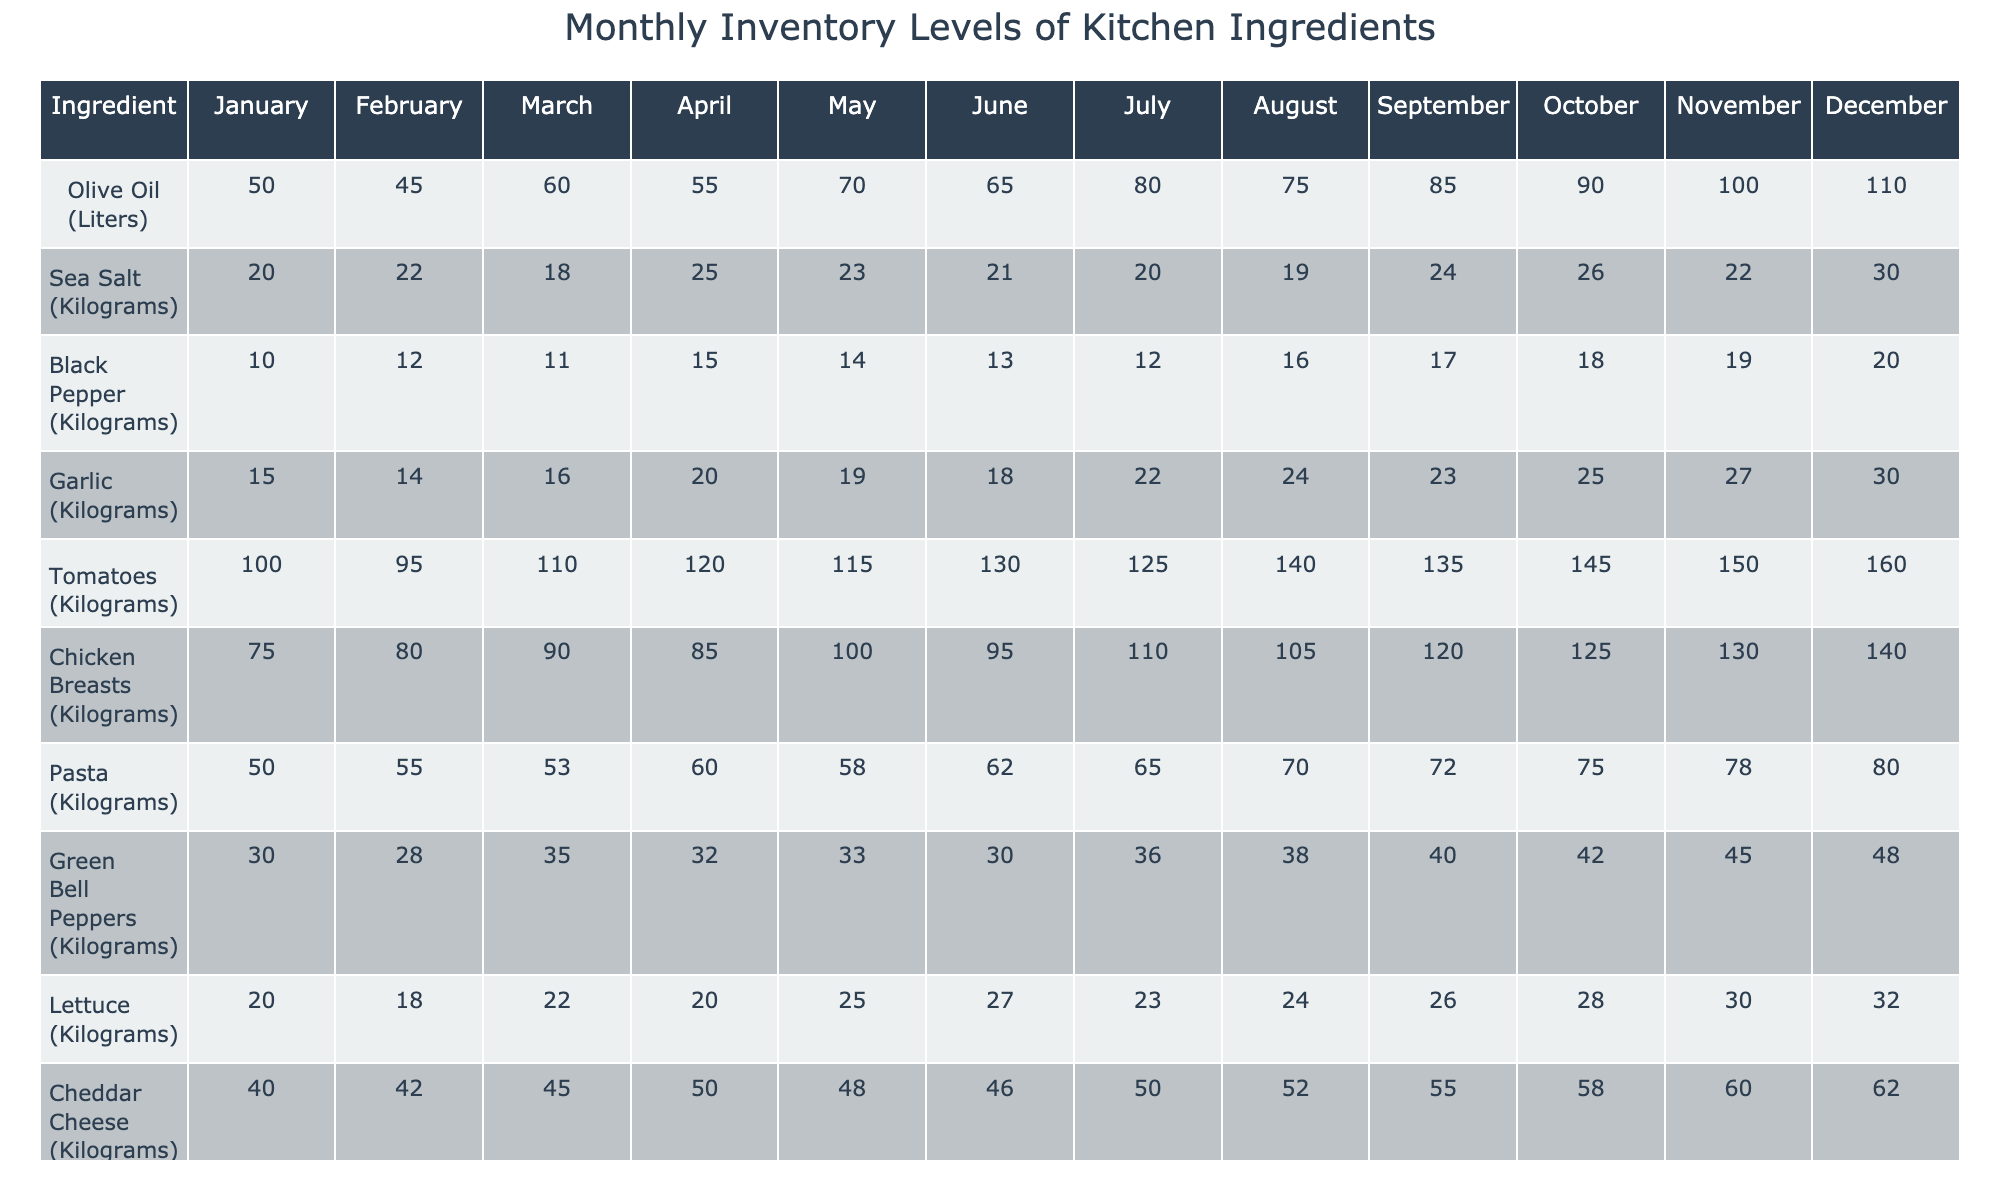What was the highest stock level of Olive Oil? The Olive Oil stock levels for the months are listed as follows: 50, 45, 60, 55, 70, 65, 80, 75, 85, 90, 100, and 110. The highest number is 110 in December.
Answer: 110 Which month had the lowest inventory of Sea Salt? The Sea Salt inventory monthly data is 20, 22, 18, 25, 23, 21, 20, 19, 24, 26, 22, and 30. The lowest inventory is 18, which occurred in March.
Answer: 18 What was the total amount of Garlic received from January to March? The Garlic inventory levels from January to March are 15, 14, and 16. To find the total: 15 + 14 + 16 = 45.
Answer: 45 Did the amount of Lettuce in April exceed the amount in March? The Lettuce amounts are 22 in March and 20 in April. Since 20 is less than 22, April did not exceed March.
Answer: No In which month did the inventory of Tomatoes increase the most compared to the previous one? The inventory values of Tomatoes are: January (100), February (95), March (110), April (120), May (115), June (130), July (125), August (140), September (135), October (145), November (150), December (160). The largest increase is from June (130) to July (125) which is a decrease, so the increase was from March (110) to April (120) = 10.
Answer: March to April What is the average stock level of Cheddar Cheese for the first half of the year? The Cheddar Cheese values from January to June are: 40, 42, 45, 50, 48, and 46. The total is 40 + 42 + 45 + 50 + 48 + 46 = 271, and the average is 271/6 = 45.17.
Answer: 45.17 Was there a month with a more than 20% increase in Black Pepper inventory compared to the previous month? The Black Pepper monthly values are 10, 12, 11, 15, 14, 13, 12, 16, 17, 18, 19, and 20. An increase of more than 20% from previous values would mean: the increase from 10 to 12 is 20%, and from 12 to 15 is an increase of 25%. So yes, there was a month (February to March) with more than a 20% increase.
Answer: Yes Calculate the overall change in Chicken Breasts inventory from January to December. For Chicken Breasts: January is 75, and December is 140. The change is calculated as 140 - 75 = 65, indicating an increase of 65 kilograms.
Answer: 65 What was the most significant increase in inventory for Green Bell Peppers? The Green Bell Peppers values are 30, 28, 35, 32, 33, 30, 36, 38, 40, 42, 45, and 48. The greatest increase occurs from August (38) to September (40), which is an increase of 2.
Answer: 2 Which ingredient had the highest average monthly inventory throughout the year? To find the average for all, sum them up and divide by 12. Olive Oil has the average (50+45+60+55+70+65+80+75+85+90+100+110)/12 = 73.75. The highest overall average belongs to Tomatoes (130.83).
Answer: Tomatoes 